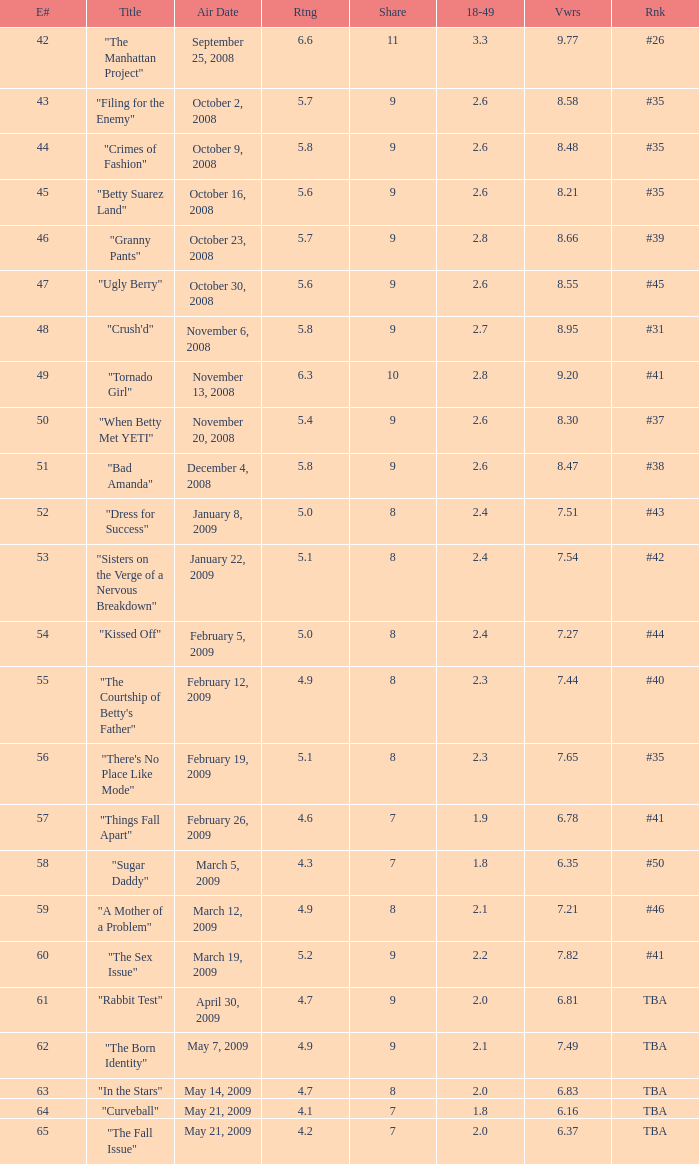What is the lowest Viewers that has an Episode #higher than 58 with a title of "curveball" less than 4.1 rating? None. 